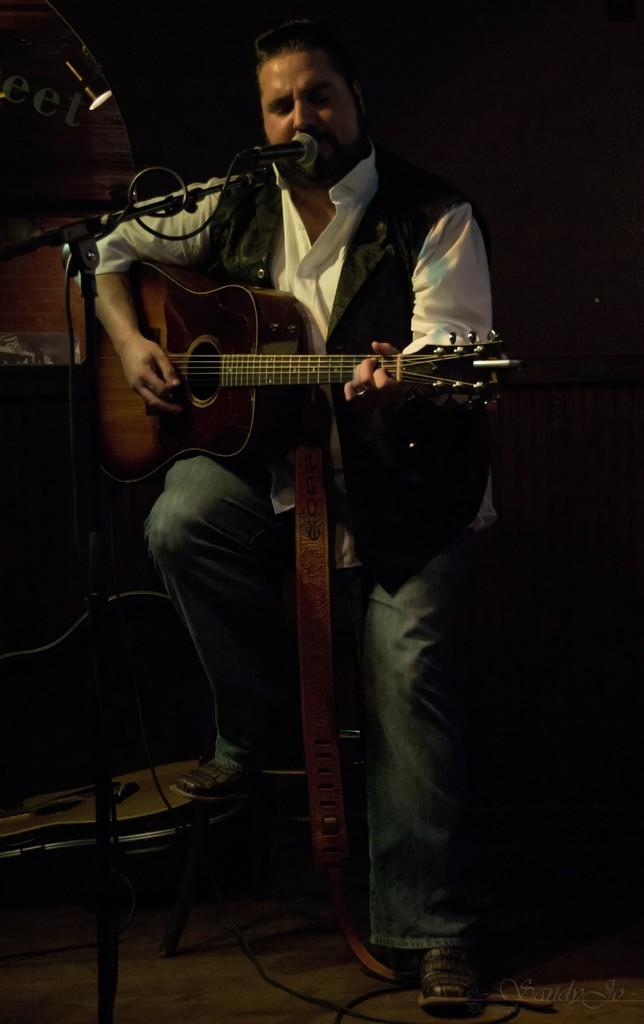How would you summarize this image in a sentence or two? In this image I see a man who is holding a guitar and is sitting in front of a mic, I can also see the light over here. 